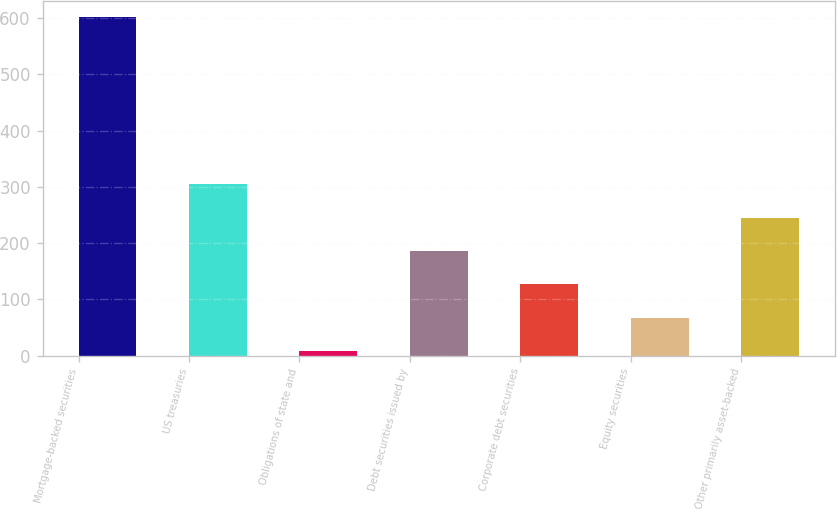<chart> <loc_0><loc_0><loc_500><loc_500><bar_chart><fcel>Mortgage-backed securities<fcel>US treasuries<fcel>Obligations of state and<fcel>Debt securities issued by<fcel>Corporate debt securities<fcel>Equity securities<fcel>Other primarily asset-backed<nl><fcel>601<fcel>304.5<fcel>8<fcel>185.9<fcel>126.6<fcel>67.3<fcel>245.2<nl></chart> 